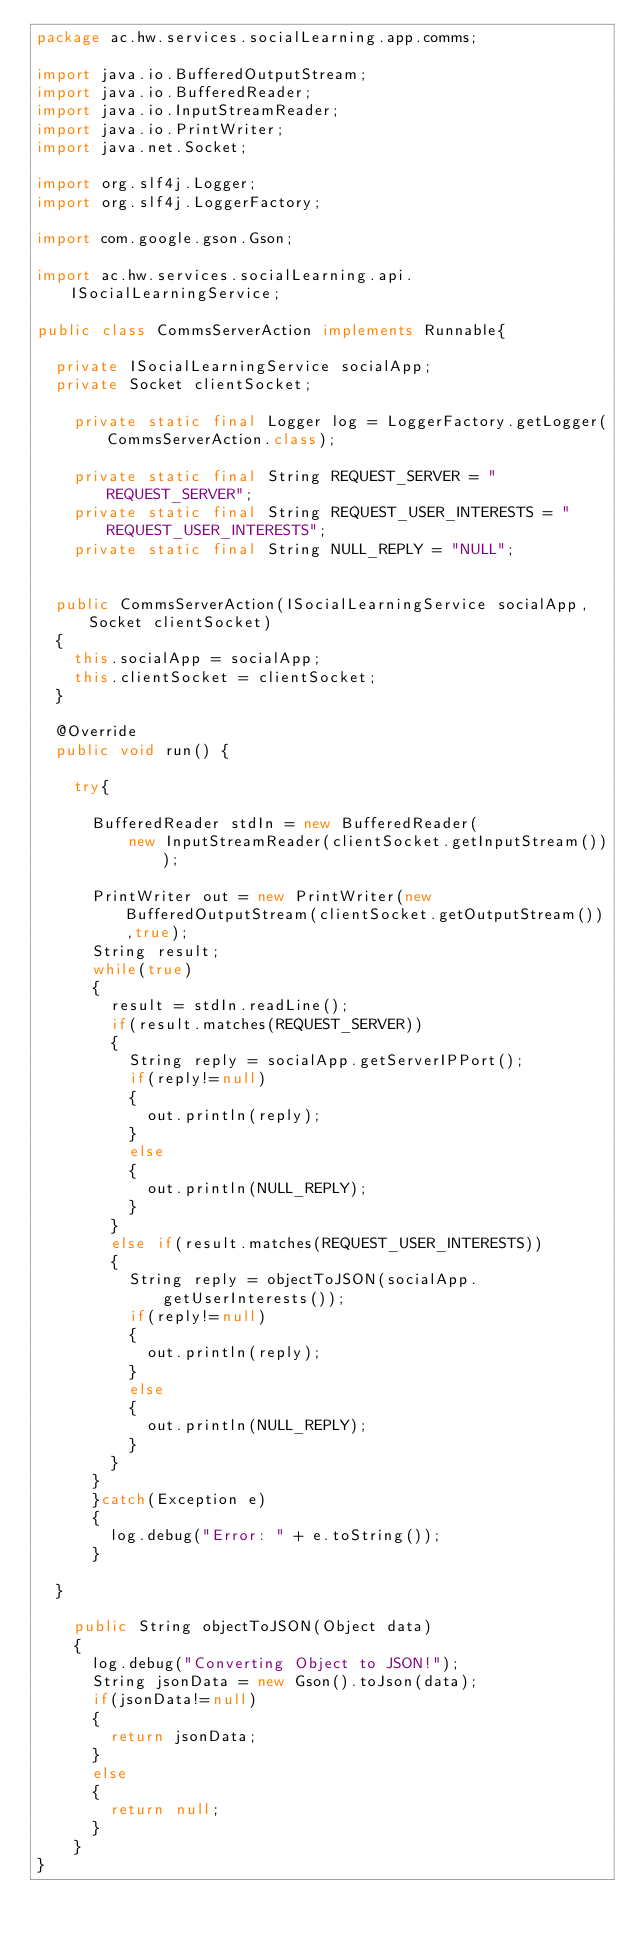<code> <loc_0><loc_0><loc_500><loc_500><_Java_>package ac.hw.services.socialLearning.app.comms;

import java.io.BufferedOutputStream;
import java.io.BufferedReader;
import java.io.InputStreamReader;
import java.io.PrintWriter;
import java.net.Socket;

import org.slf4j.Logger;
import org.slf4j.LoggerFactory;

import com.google.gson.Gson;

import ac.hw.services.socialLearning.api.ISocialLearningService;

public class CommsServerAction implements Runnable{
	
	private ISocialLearningService socialApp;
	private Socket clientSocket;
	
    private static final Logger log = LoggerFactory.getLogger(CommsServerAction.class);
    
    private static final String REQUEST_SERVER = "REQUEST_SERVER";
    private static final String REQUEST_USER_INTERESTS = "REQUEST_USER_INTERESTS";
    private static final String NULL_REPLY = "NULL";

	
	public CommsServerAction(ISocialLearningService socialApp, Socket clientSocket)
	{
		this.socialApp = socialApp;
		this.clientSocket = clientSocket;
	}

	@Override
	public void run() {
		
		try{
			
			BufferedReader stdIn = new BufferedReader(
					new InputStreamReader(clientSocket.getInputStream()));
			
			PrintWriter out = new PrintWriter(new BufferedOutputStream(clientSocket.getOutputStream()),true);
			String result;
			while(true)
			{
				result = stdIn.readLine();
				if(result.matches(REQUEST_SERVER))
				{
					String reply = socialApp.getServerIPPort();
					if(reply!=null)
					{
						out.println(reply);
					}
					else
					{
						out.println(NULL_REPLY);
					}
				}
				else if(result.matches(REQUEST_USER_INTERESTS))
				{
					String reply = objectToJSON(socialApp.getUserInterests());
					if(reply!=null)
					{
						out.println(reply);
					}
					else
					{
						out.println(NULL_REPLY);
					}
				}
			}
			}catch(Exception e)
			{
				log.debug("Error: " + e.toString());
			}
		
	}

		public String objectToJSON(Object data)
		{
			log.debug("Converting Object to JSON!");
			String jsonData = new Gson().toJson(data);
			if(jsonData!=null)
			{
				return jsonData;
			}
			else
			{
				return null;
			}
		}
}
</code> 